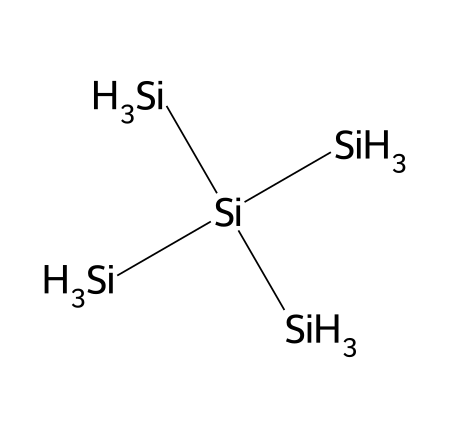What is the total number of silicon atoms in this structure? The SMILES representation indicates the presence of 5 silicon atoms, as the main element (Si) is explicitly mentioned four times as part of the backbone and appears once as part of a branched structure.
Answer: five How many hydrogen atoms are attached to the silicon atoms? In the SMILES representation, each of the three terminal silicon atoms has three hydrogen atoms attached (as indicated by [SiH3]) while the central silicon atom does not have any attached hydrogen. Therefore, there are a total of 9 hydrogen atoms (3 from each of the 3 terminal silicons).
Answer: nine What type of bonding is primarily present in silicon quantum dots? The bonding in silicon quantum dots is primarily covalent, as silicon forms covalent bonds with other silicon atoms and hydrogen atoms in this structure.
Answer: covalent Can this chemical structure be classified as a quantum dot? Yes, this specific arrangement of silicon atoms typically forms a nanoscale particle, which is a characteristic of quantum dots, often used for quantum memory applications.
Answer: yes What is the significance of the branching in this chemical structure for quantum applications? The branching allows for increased surface area and potentially facilitates the electronic properties that are critical in quantum memory, enhancing efficiency and performance.
Answer: electronic properties 